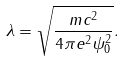<formula> <loc_0><loc_0><loc_500><loc_500>\lambda = \sqrt { \frac { m c ^ { 2 } } { 4 \pi e ^ { 2 } \psi _ { 0 } ^ { 2 } } } .</formula> 